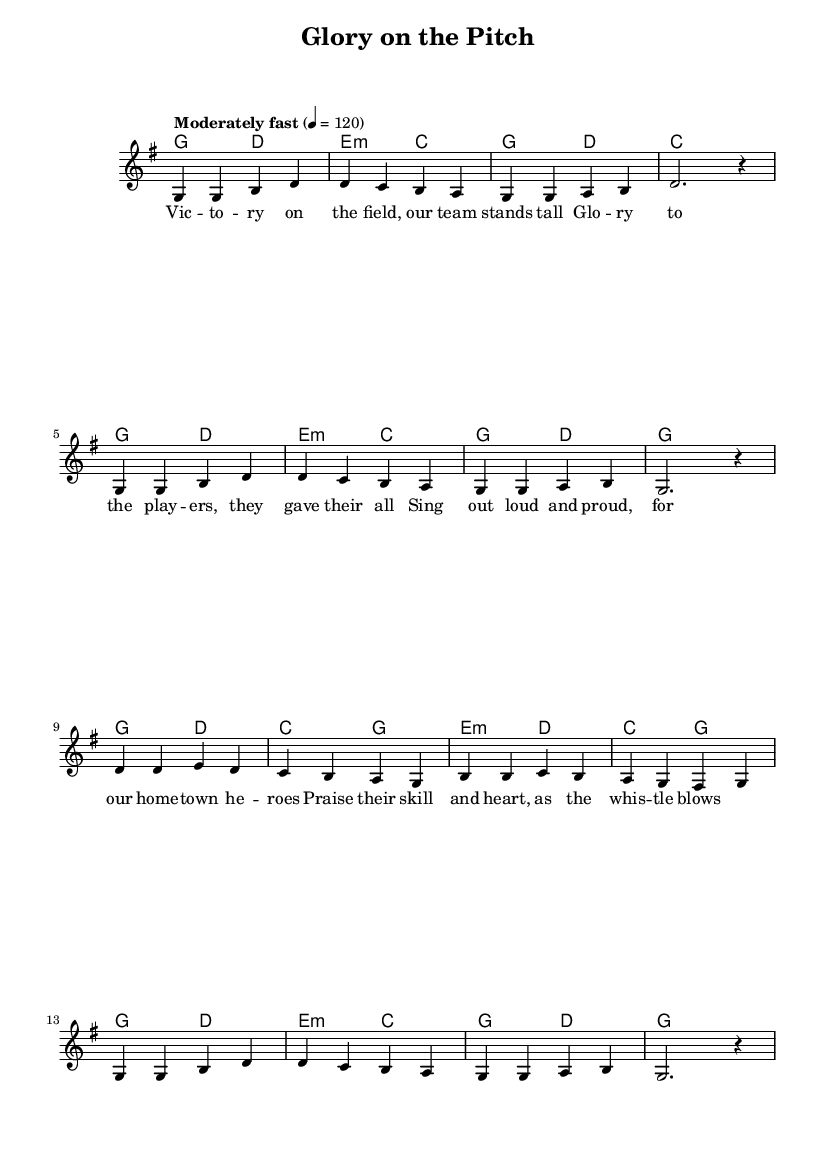What is the key signature of this music? The key signature is G major, which has one sharp (F#). This can be identified by looking at the key signature at the beginning of the staff.
Answer: G major What is the time signature of this music? The time signature is 4/4, indicated right after the key signature. It shows that there are four beats per measure, and the quarter note gets one beat.
Answer: 4/4 What is the tempo marking for this piece? The tempo marking is "Moderately fast" with a metronome marking of 120 beats per minute. This can be found at the beginning of the score, indicating how fast the music should be played.
Answer: Moderately fast, 120 How many measures are in the melody? The melody contains 16 measures, which can be counted by looking at the grouping in the score and where the bar lines are placed. Each group of notes between the vertical lines represents one measure.
Answer: 16 What is the harmonic structure of the first line? The harmonic structure of the first line consists of the chords G, D, E minor, and C, which can be observed in the chord symbols written above the melody notes in the first line.
Answer: G, D, E minor, C What thematic elements are portrayed in the lyrics? The lyrics celebrate victory, teamwork, and community pride, reflecting themes typical of gospel music. They emphasize joy and gratitude, as seen in phrases such as "Victory on the field" and "Praise their skill and heart."
Answer: Victory, teamwork, community pride Which musical genre does this piece belong to? This piece belongs to the genre of gospel music, which is characterized by its religious themes and communal aspects, often used to celebrate events like sports victories, as seen in the lyrics and context of the melody.
Answer: Gospel music 